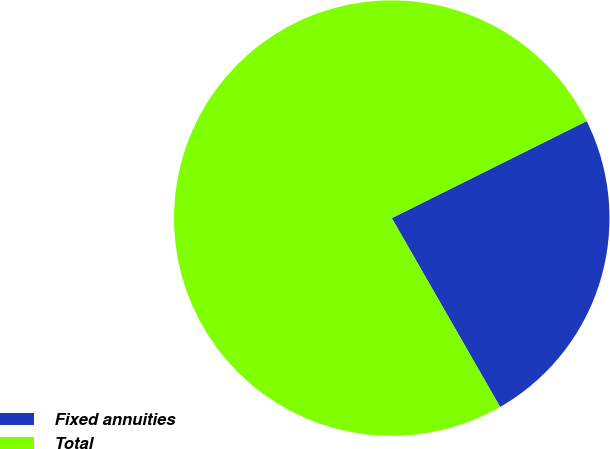<chart> <loc_0><loc_0><loc_500><loc_500><pie_chart><fcel>Fixed annuities<fcel>Total<nl><fcel>24.06%<fcel>75.94%<nl></chart> 